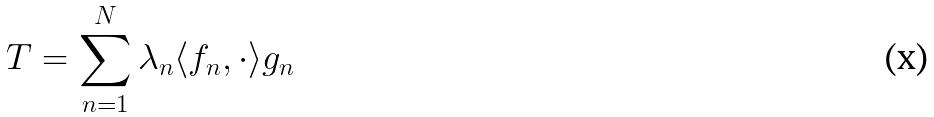Convert formula to latex. <formula><loc_0><loc_0><loc_500><loc_500>T = \sum _ { n = 1 } ^ { N } \lambda _ { n } \langle f _ { n } , \cdot \rangle g _ { n }</formula> 